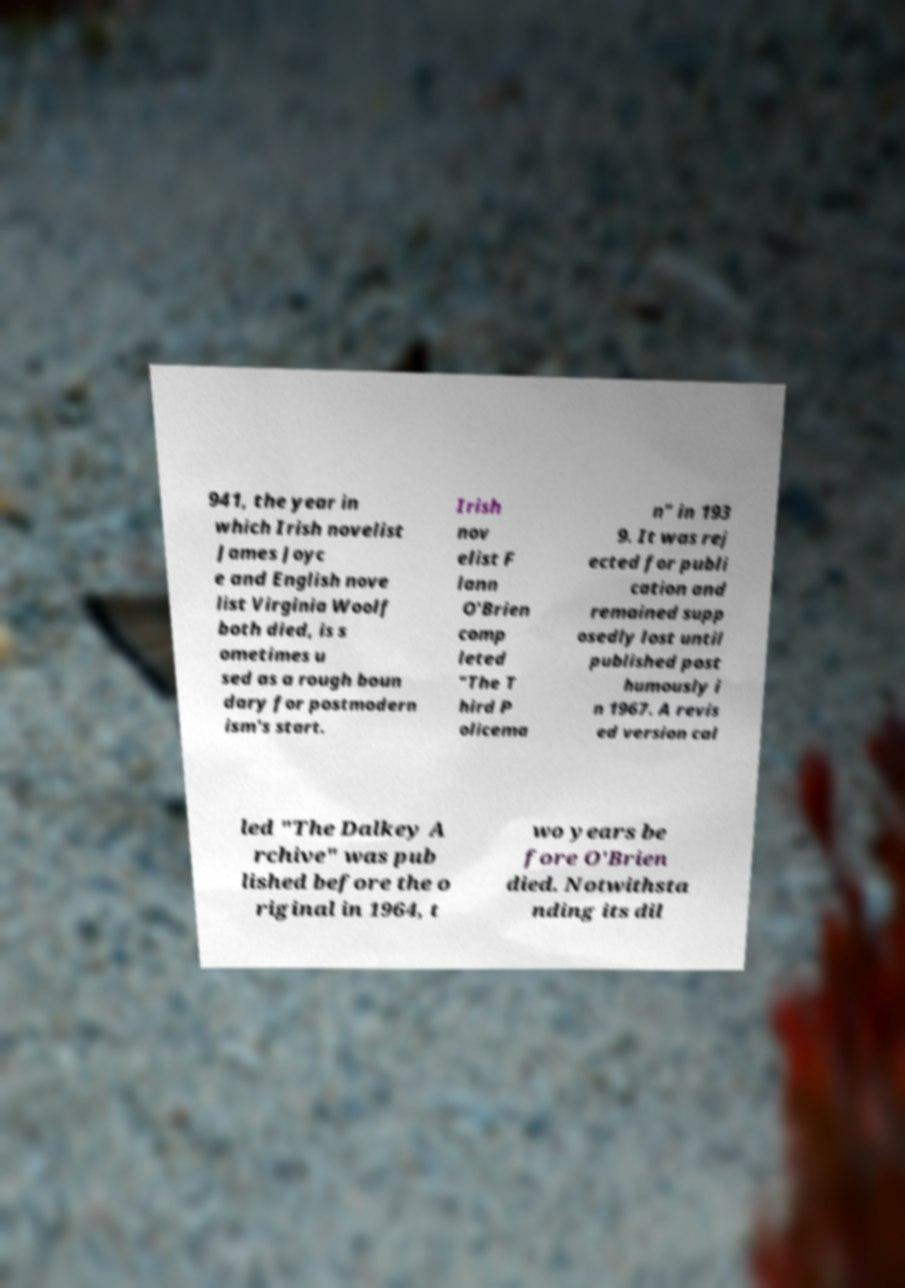Please identify and transcribe the text found in this image. 941, the year in which Irish novelist James Joyc e and English nove list Virginia Woolf both died, is s ometimes u sed as a rough boun dary for postmodern ism's start. Irish nov elist F lann O'Brien comp leted "The T hird P olicema n" in 193 9. It was rej ected for publi cation and remained supp osedly lost until published post humously i n 1967. A revis ed version cal led "The Dalkey A rchive" was pub lished before the o riginal in 1964, t wo years be fore O'Brien died. Notwithsta nding its dil 